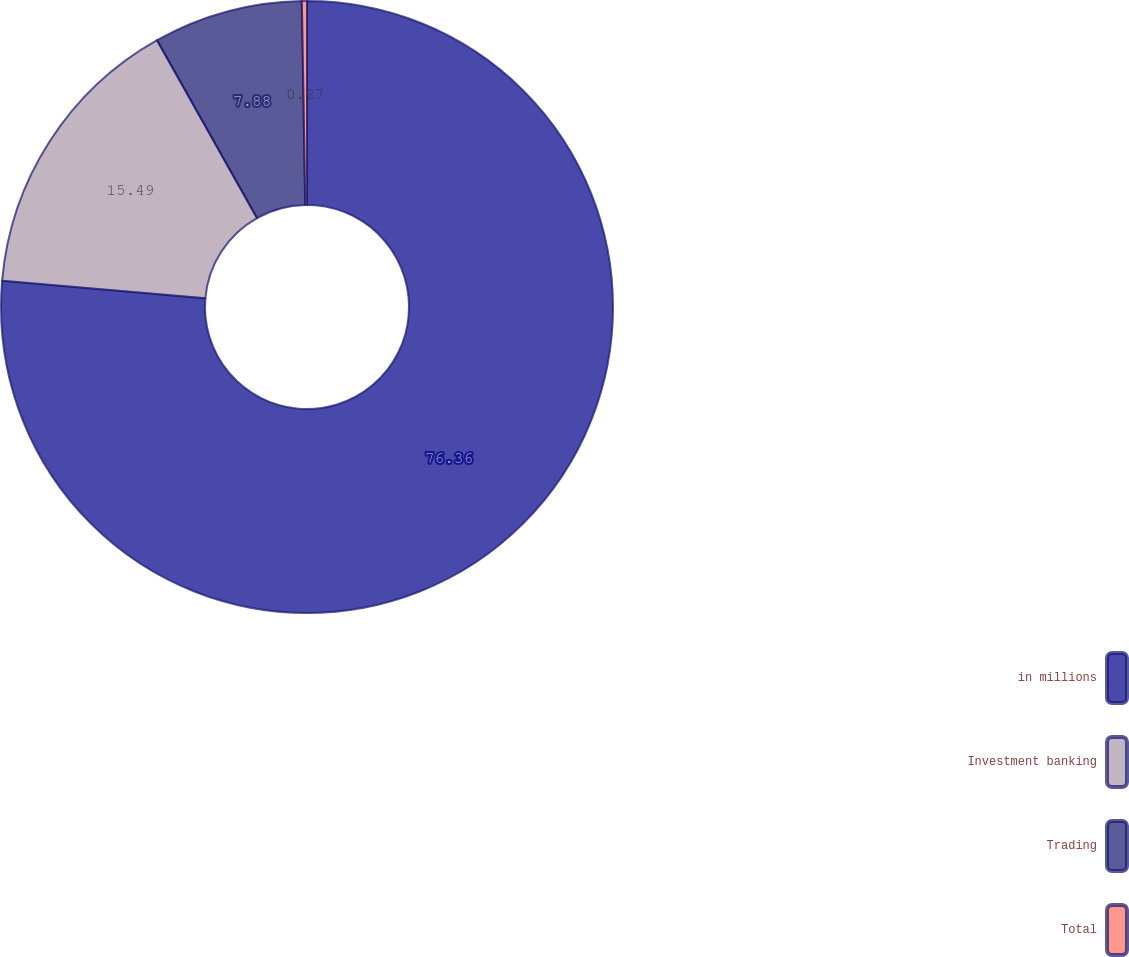Convert chart. <chart><loc_0><loc_0><loc_500><loc_500><pie_chart><fcel>in millions<fcel>Investment banking<fcel>Trading<fcel>Total<nl><fcel>76.37%<fcel>15.49%<fcel>7.88%<fcel>0.27%<nl></chart> 